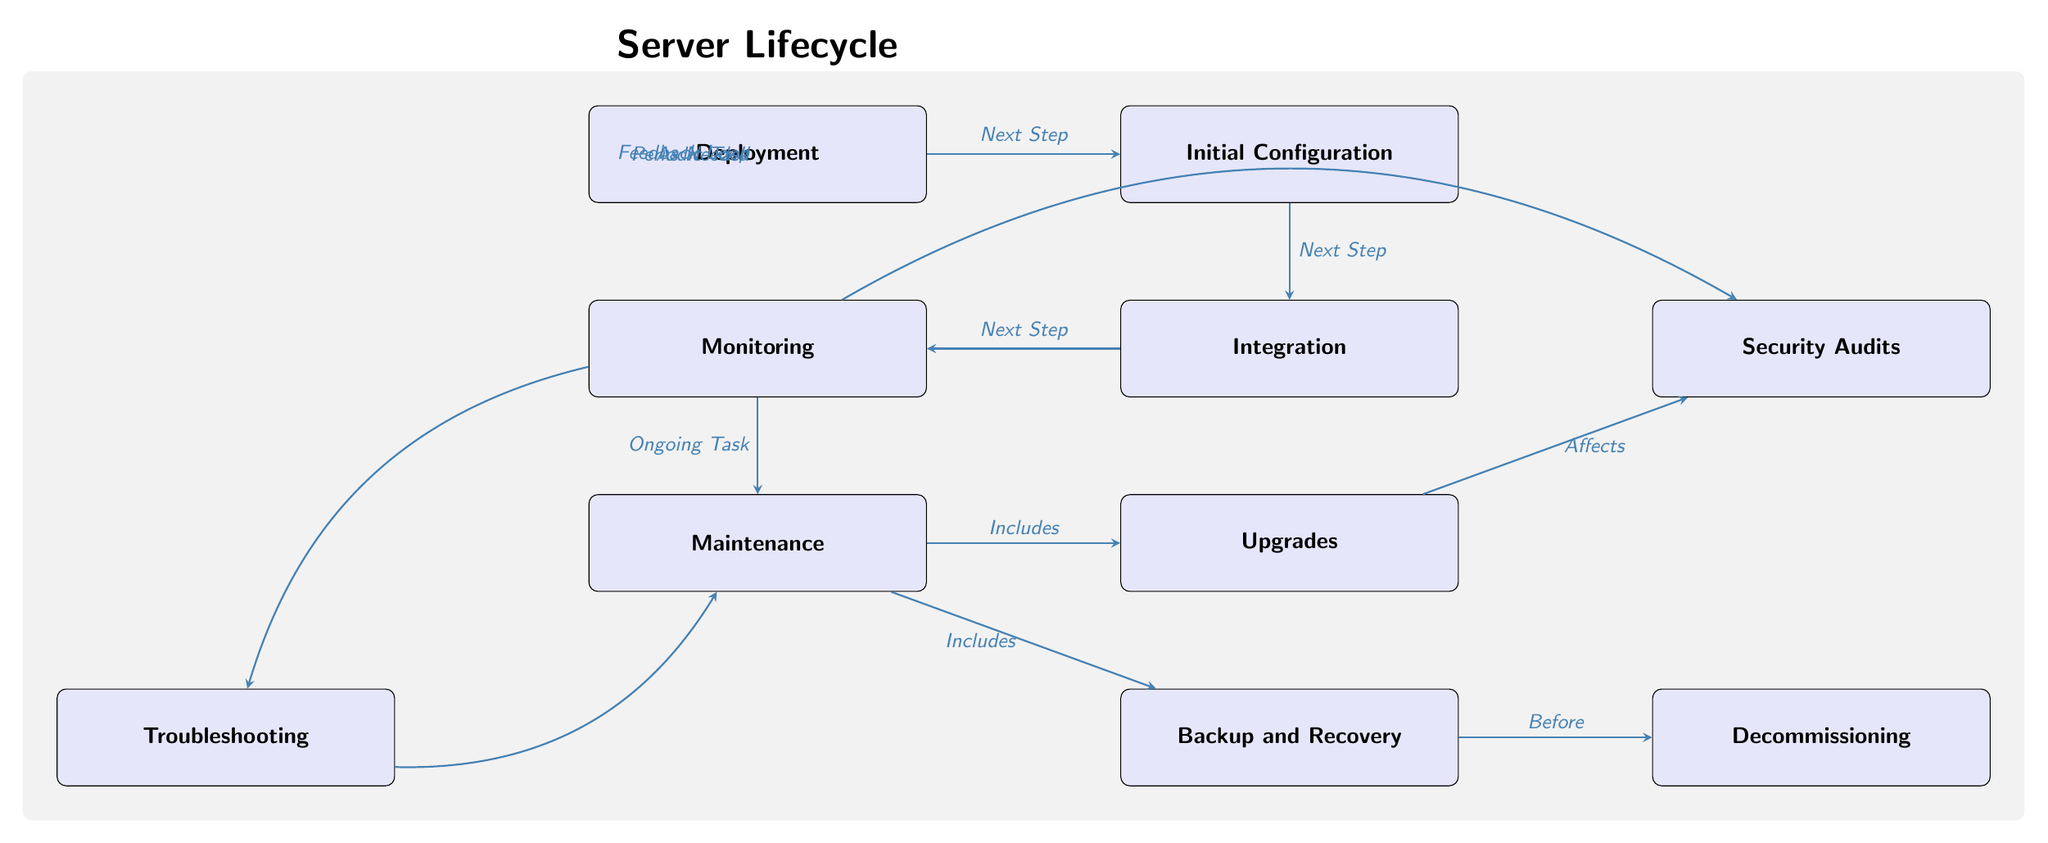What is the first step in the server lifecycle? The first step in the server lifecycle is represented by the node labeled "Deployment." This is the starting point from where the lifecycle begins, indicating the initial placement and setup of the server in the infrastructure.
Answer: Deployment How many tasks are included after the monitoring node? After the monitoring node, there are three tasks listed: maintenance, security audits, and troubleshooting. This is determined by counting the nodes directly connected to the monitoring node: maintenance (down), security audits (up right), and troubleshooting (down left).
Answer: Three Which task directly follows initial configuration? The task that directly follows the "Initial Configuration" node is "Integration." This is indicated by the arrow connecting them, showing a clear flow from one task to the next in the lifecycle.
Answer: Integration What are the two aspects included under maintenance? The two aspects included under "Maintenance" are "Upgrades" and "Backup and Recovery." This can be seen through the arrows that come out of the maintenance node that indicate it includes these two tasks.
Answer: Upgrades and Backup and Recovery What does the arrow from troubleshooting indicate? The arrow from "Troubleshooting" indicates a feedback loop back to "Maintenance." This means that issues encountered during troubleshooting can lead to further maintenance activities, illustrating the interconnected nature of these tasks.
Answer: Feedback Loop What is the last stage of the server lifecycle? The last stage of the server lifecycle is represented by the node labeled "Decommissioning." This stage comes after all maintenance and backup tasks, marking the end of the server's lifecycle.
Answer: Decommissioning How does "Monitoring" relate to "Security Audits"? "Monitoring" periodically leads to "Security Audits," as shown by the arrow bending from "Monitoring" to "Security Audits." This indicates that regular monitoring prompts security checks to ensure compliance and security standards.
Answer: Periodic Task How many nodes are there in total? The total number of nodes in the diagram is ten, which includes all tasks from deployment to decommissioning. Each task is distinctly visualized as a node within the lifecycle.
Answer: Ten What action is required before decommissioning? The action required before moving to "Decommissioning" is "Backup and Recovery," as indicated by the arrow pointing directly from "Backup and Recovery" to "Decommissioning." This shows that backups must be performed prior to taking the server offline.
Answer: Before 